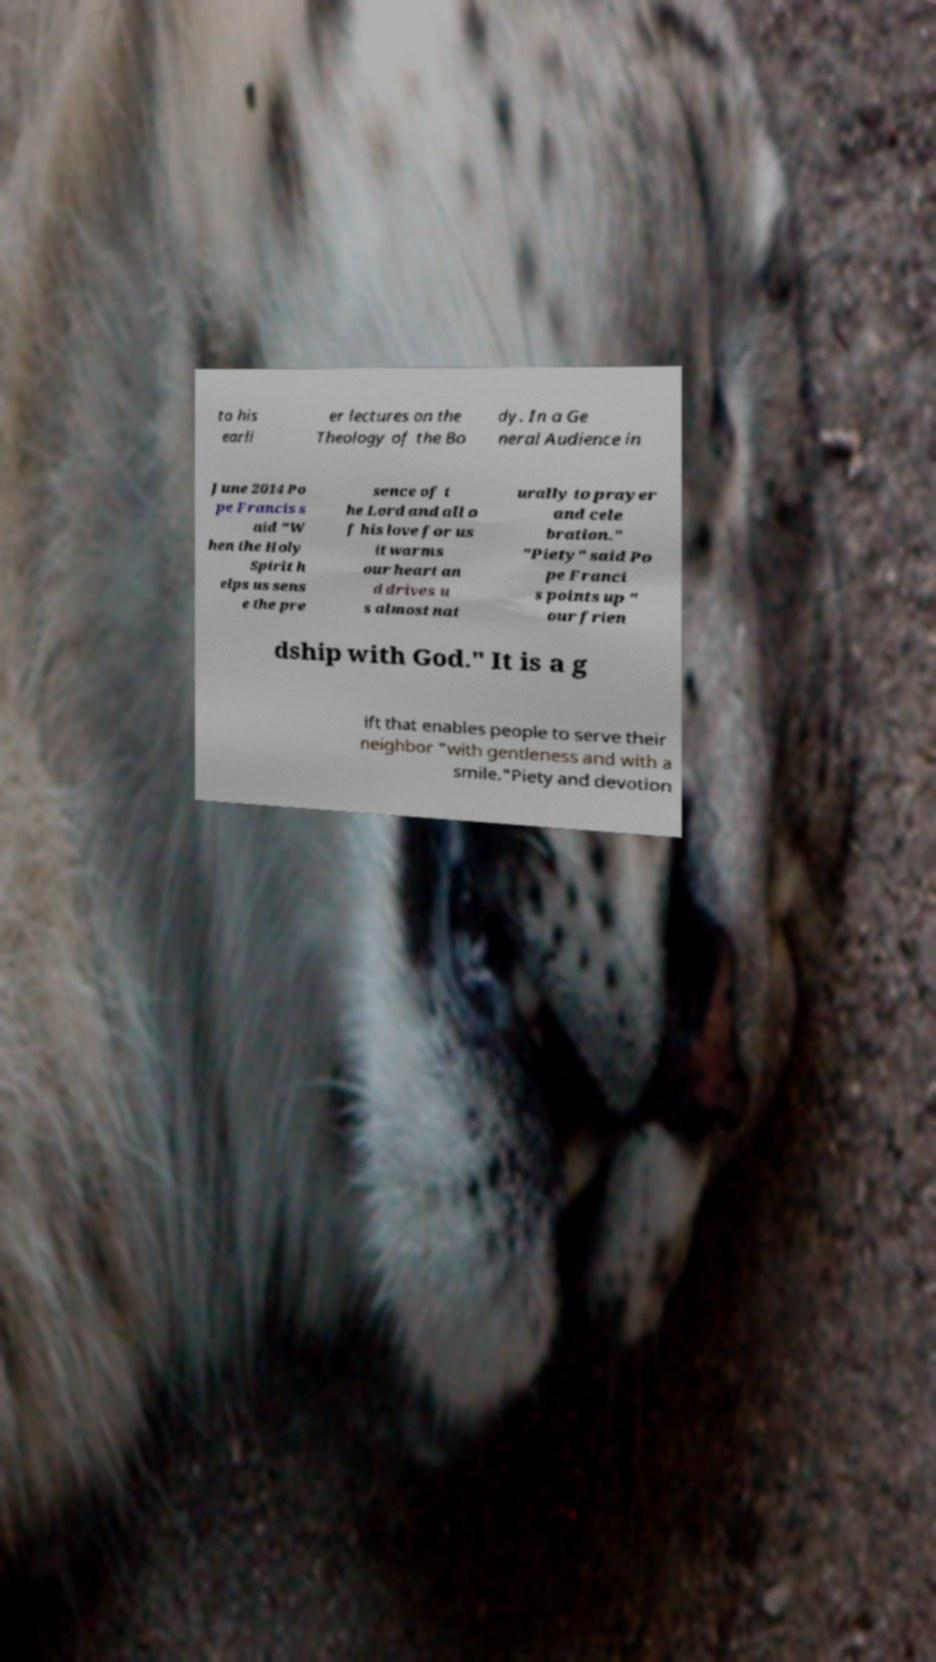I need the written content from this picture converted into text. Can you do that? to his earli er lectures on the Theology of the Bo dy. In a Ge neral Audience in June 2014 Po pe Francis s aid "W hen the Holy Spirit h elps us sens e the pre sence of t he Lord and all o f his love for us it warms our heart an d drives u s almost nat urally to prayer and cele bration." "Piety" said Po pe Franci s points up " our frien dship with God." It is a g ift that enables people to serve their neighbor "with gentleness and with a smile."Piety and devotion 